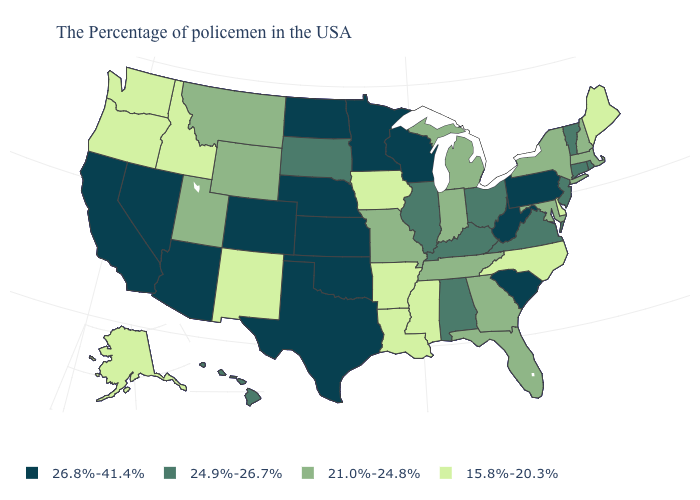Does West Virginia have the highest value in the South?
Keep it brief. Yes. What is the value of Nevada?
Answer briefly. 26.8%-41.4%. What is the value of New Jersey?
Keep it brief. 24.9%-26.7%. Among the states that border Idaho , which have the lowest value?
Give a very brief answer. Washington, Oregon. Name the states that have a value in the range 21.0%-24.8%?
Keep it brief. Massachusetts, New Hampshire, New York, Maryland, Florida, Georgia, Michigan, Indiana, Tennessee, Missouri, Wyoming, Utah, Montana. Which states have the highest value in the USA?
Keep it brief. Pennsylvania, South Carolina, West Virginia, Wisconsin, Minnesota, Kansas, Nebraska, Oklahoma, Texas, North Dakota, Colorado, Arizona, Nevada, California. What is the highest value in states that border Wyoming?
Keep it brief. 26.8%-41.4%. How many symbols are there in the legend?
Give a very brief answer. 4. Does New Hampshire have the same value as Alaska?
Short answer required. No. What is the highest value in the Northeast ?
Keep it brief. 26.8%-41.4%. What is the value of Alabama?
Write a very short answer. 24.9%-26.7%. What is the value of South Carolina?
Write a very short answer. 26.8%-41.4%. What is the value of Rhode Island?
Give a very brief answer. 24.9%-26.7%. Does Alaska have the lowest value in the USA?
Keep it brief. Yes. 